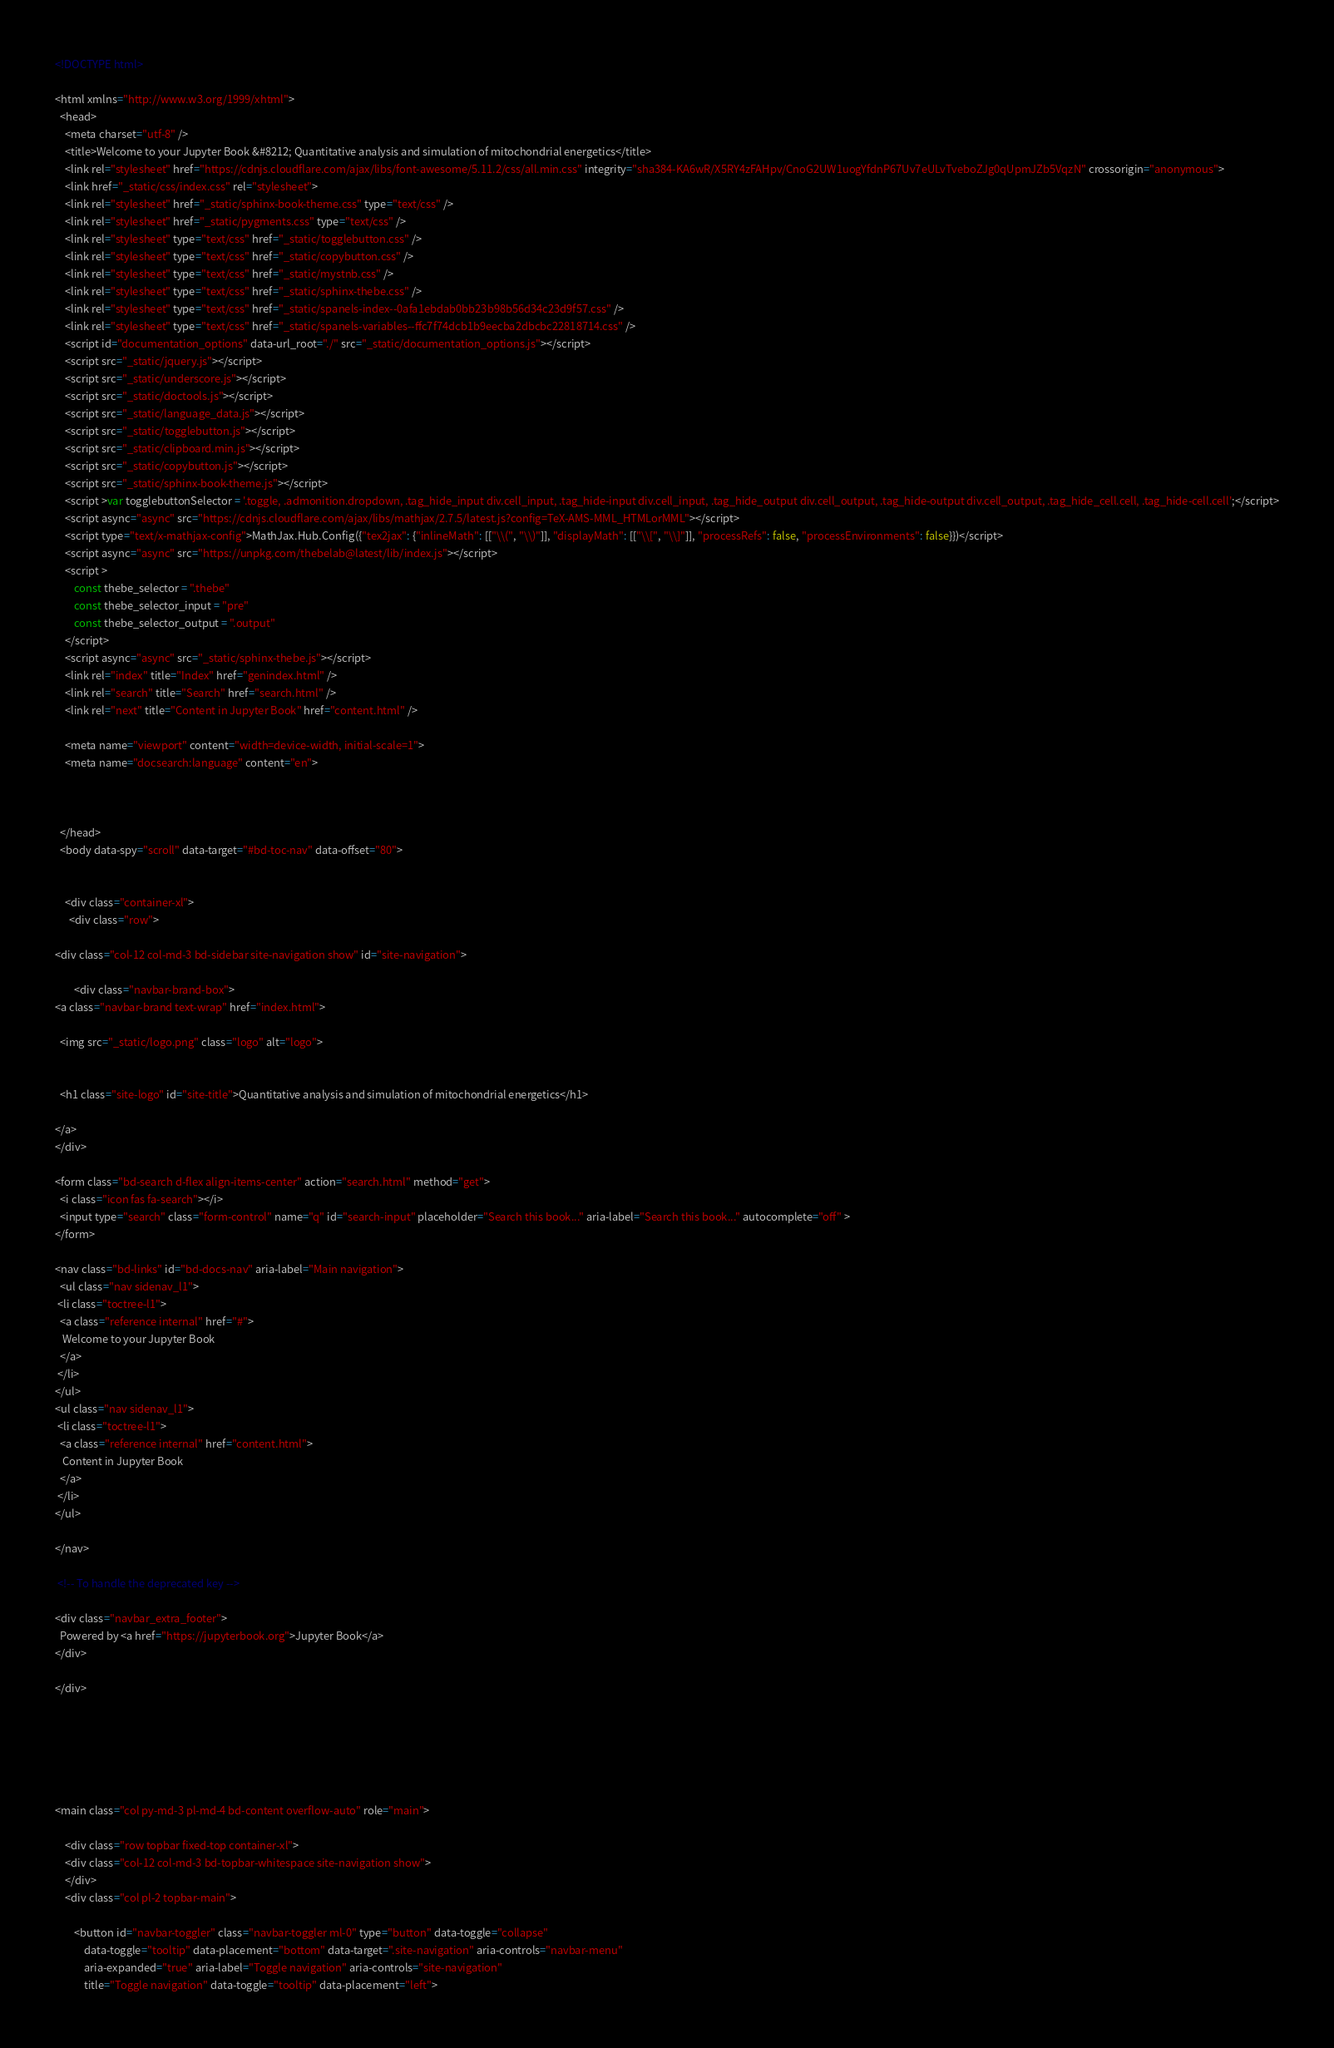<code> <loc_0><loc_0><loc_500><loc_500><_HTML_>

<!DOCTYPE html>

<html xmlns="http://www.w3.org/1999/xhtml">
  <head>
    <meta charset="utf-8" />
    <title>Welcome to your Jupyter Book &#8212; Quantitative analysis and simulation of mitochondrial energetics</title>
    <link rel="stylesheet" href="https://cdnjs.cloudflare.com/ajax/libs/font-awesome/5.11.2/css/all.min.css" integrity="sha384-KA6wR/X5RY4zFAHpv/CnoG2UW1uogYfdnP67Uv7eULvTveboZJg0qUpmJZb5VqzN" crossorigin="anonymous">
    <link href="_static/css/index.css" rel="stylesheet">
    <link rel="stylesheet" href="_static/sphinx-book-theme.css" type="text/css" />
    <link rel="stylesheet" href="_static/pygments.css" type="text/css" />
    <link rel="stylesheet" type="text/css" href="_static/togglebutton.css" />
    <link rel="stylesheet" type="text/css" href="_static/copybutton.css" />
    <link rel="stylesheet" type="text/css" href="_static/mystnb.css" />
    <link rel="stylesheet" type="text/css" href="_static/sphinx-thebe.css" />
    <link rel="stylesheet" type="text/css" href="_static/spanels-index--0afa1ebdab0bb23b98b56d34c23d9f57.css" />
    <link rel="stylesheet" type="text/css" href="_static/spanels-variables--ffc7f74dcb1b9eecba2dbcbc22818714.css" />
    <script id="documentation_options" data-url_root="./" src="_static/documentation_options.js"></script>
    <script src="_static/jquery.js"></script>
    <script src="_static/underscore.js"></script>
    <script src="_static/doctools.js"></script>
    <script src="_static/language_data.js"></script>
    <script src="_static/togglebutton.js"></script>
    <script src="_static/clipboard.min.js"></script>
    <script src="_static/copybutton.js"></script>
    <script src="_static/sphinx-book-theme.js"></script>
    <script >var togglebuttonSelector = '.toggle, .admonition.dropdown, .tag_hide_input div.cell_input, .tag_hide-input div.cell_input, .tag_hide_output div.cell_output, .tag_hide-output div.cell_output, .tag_hide_cell.cell, .tag_hide-cell.cell';</script>
    <script async="async" src="https://cdnjs.cloudflare.com/ajax/libs/mathjax/2.7.5/latest.js?config=TeX-AMS-MML_HTMLorMML"></script>
    <script type="text/x-mathjax-config">MathJax.Hub.Config({"tex2jax": {"inlineMath": [["\\(", "\\)"]], "displayMath": [["\\[", "\\]"]], "processRefs": false, "processEnvironments": false}})</script>
    <script async="async" src="https://unpkg.com/thebelab@latest/lib/index.js"></script>
    <script >
        const thebe_selector = ".thebe"
        const thebe_selector_input = "pre"
        const thebe_selector_output = ".output"
    </script>
    <script async="async" src="_static/sphinx-thebe.js"></script>
    <link rel="index" title="Index" href="genindex.html" />
    <link rel="search" title="Search" href="search.html" />
    <link rel="next" title="Content in Jupyter Book" href="content.html" />

    <meta name="viewport" content="width=device-width, initial-scale=1">
    <meta name="docsearch:language" content="en">



  </head>
  <body data-spy="scroll" data-target="#bd-toc-nav" data-offset="80">
    

    <div class="container-xl">
      <div class="row">
          
<div class="col-12 col-md-3 bd-sidebar site-navigation show" id="site-navigation">
    
        <div class="navbar-brand-box">
<a class="navbar-brand text-wrap" href="index.html">
  
  <img src="_static/logo.png" class="logo" alt="logo">
  
  
  <h1 class="site-logo" id="site-title">Quantitative analysis and simulation of mitochondrial energetics</h1>
  
</a>
</div>

<form class="bd-search d-flex align-items-center" action="search.html" method="get">
  <i class="icon fas fa-search"></i>
  <input type="search" class="form-control" name="q" id="search-input" placeholder="Search this book..." aria-label="Search this book..." autocomplete="off" >
</form>

<nav class="bd-links" id="bd-docs-nav" aria-label="Main navigation">
  <ul class="nav sidenav_l1">
 <li class="toctree-l1">
  <a class="reference internal" href="#">
   Welcome to your Jupyter Book
  </a>
 </li>
</ul>
<ul class="nav sidenav_l1">
 <li class="toctree-l1">
  <a class="reference internal" href="content.html">
   Content in Jupyter Book
  </a>
 </li>
</ul>

</nav>

 <!-- To handle the deprecated key -->

<div class="navbar_extra_footer">
  Powered by <a href="https://jupyterbook.org">Jupyter Book</a>
</div>

</div>


          


          
<main class="col py-md-3 pl-md-4 bd-content overflow-auto" role="main">
    
    <div class="row topbar fixed-top container-xl">
    <div class="col-12 col-md-3 bd-topbar-whitespace site-navigation show">
    </div>
    <div class="col pl-2 topbar-main">
        
        <button id="navbar-toggler" class="navbar-toggler ml-0" type="button" data-toggle="collapse"
            data-toggle="tooltip" data-placement="bottom" data-target=".site-navigation" aria-controls="navbar-menu"
            aria-expanded="true" aria-label="Toggle navigation" aria-controls="site-navigation"
            title="Toggle navigation" data-toggle="tooltip" data-placement="left"></code> 